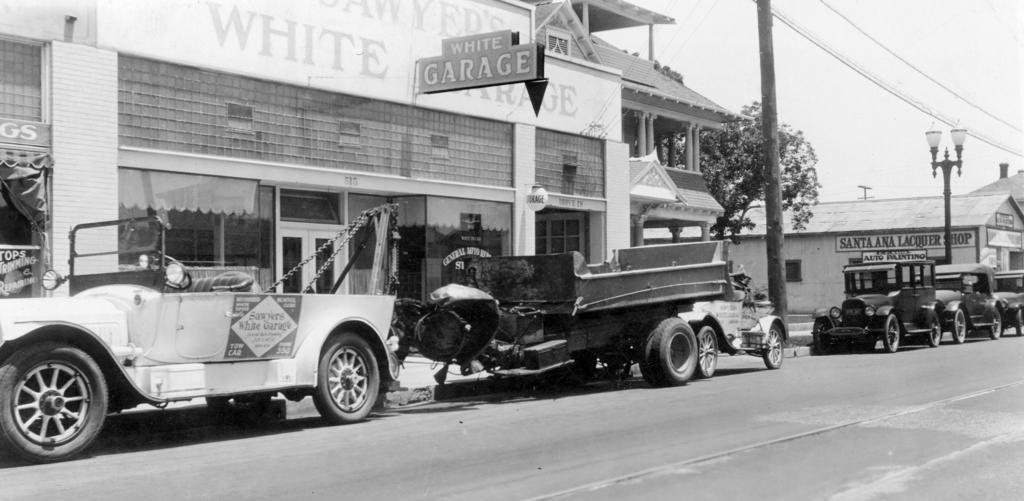Can you describe this image briefly? This is a black and white image there are few cars and trucks on the side of the road with building beside it and a tree in the middle along with street lights and above its sky. 